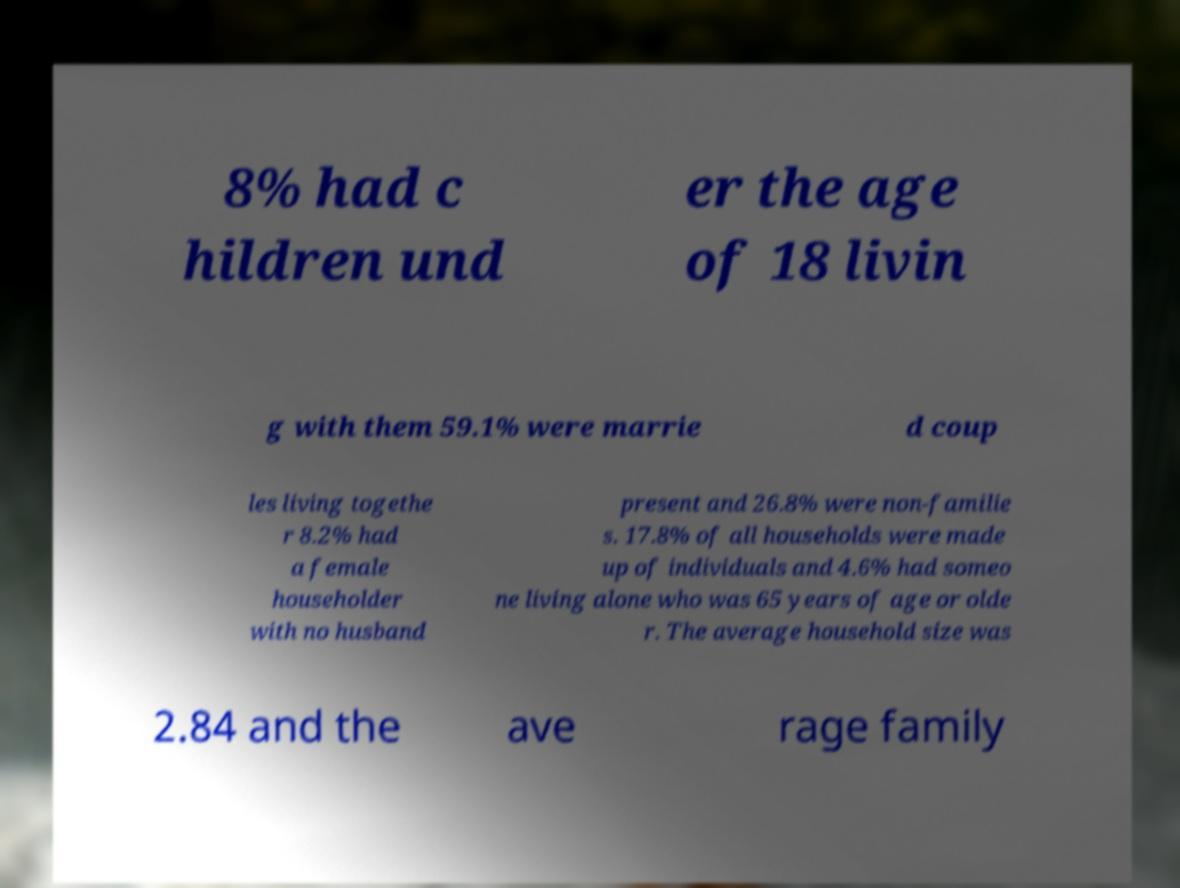For documentation purposes, I need the text within this image transcribed. Could you provide that? 8% had c hildren und er the age of 18 livin g with them 59.1% were marrie d coup les living togethe r 8.2% had a female householder with no husband present and 26.8% were non-familie s. 17.8% of all households were made up of individuals and 4.6% had someo ne living alone who was 65 years of age or olde r. The average household size was 2.84 and the ave rage family 